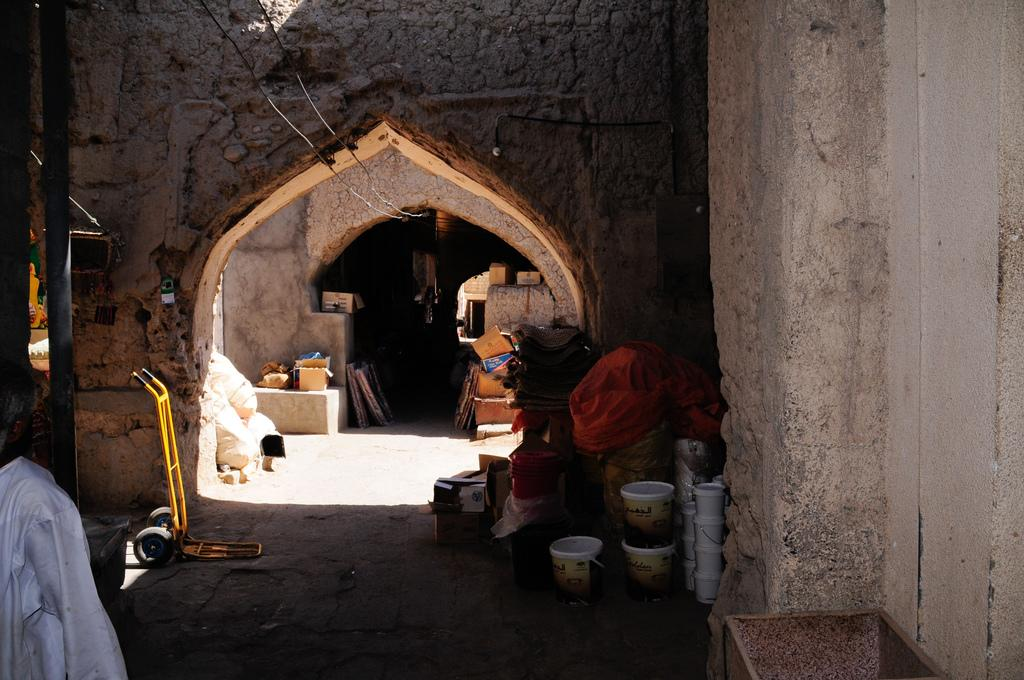What objects are located on the right side of the image? There are buckets on the right side of the image. What type of structures can be seen in the image? There are walls visible in the image. Where is the person standing in the image? The person is standing on the left side of the image. What type of request is the person making with their mouth in the image? There is no indication of a request or the person's mouth in the image. What type of minister is present in the image? There is no minister present in the image. 